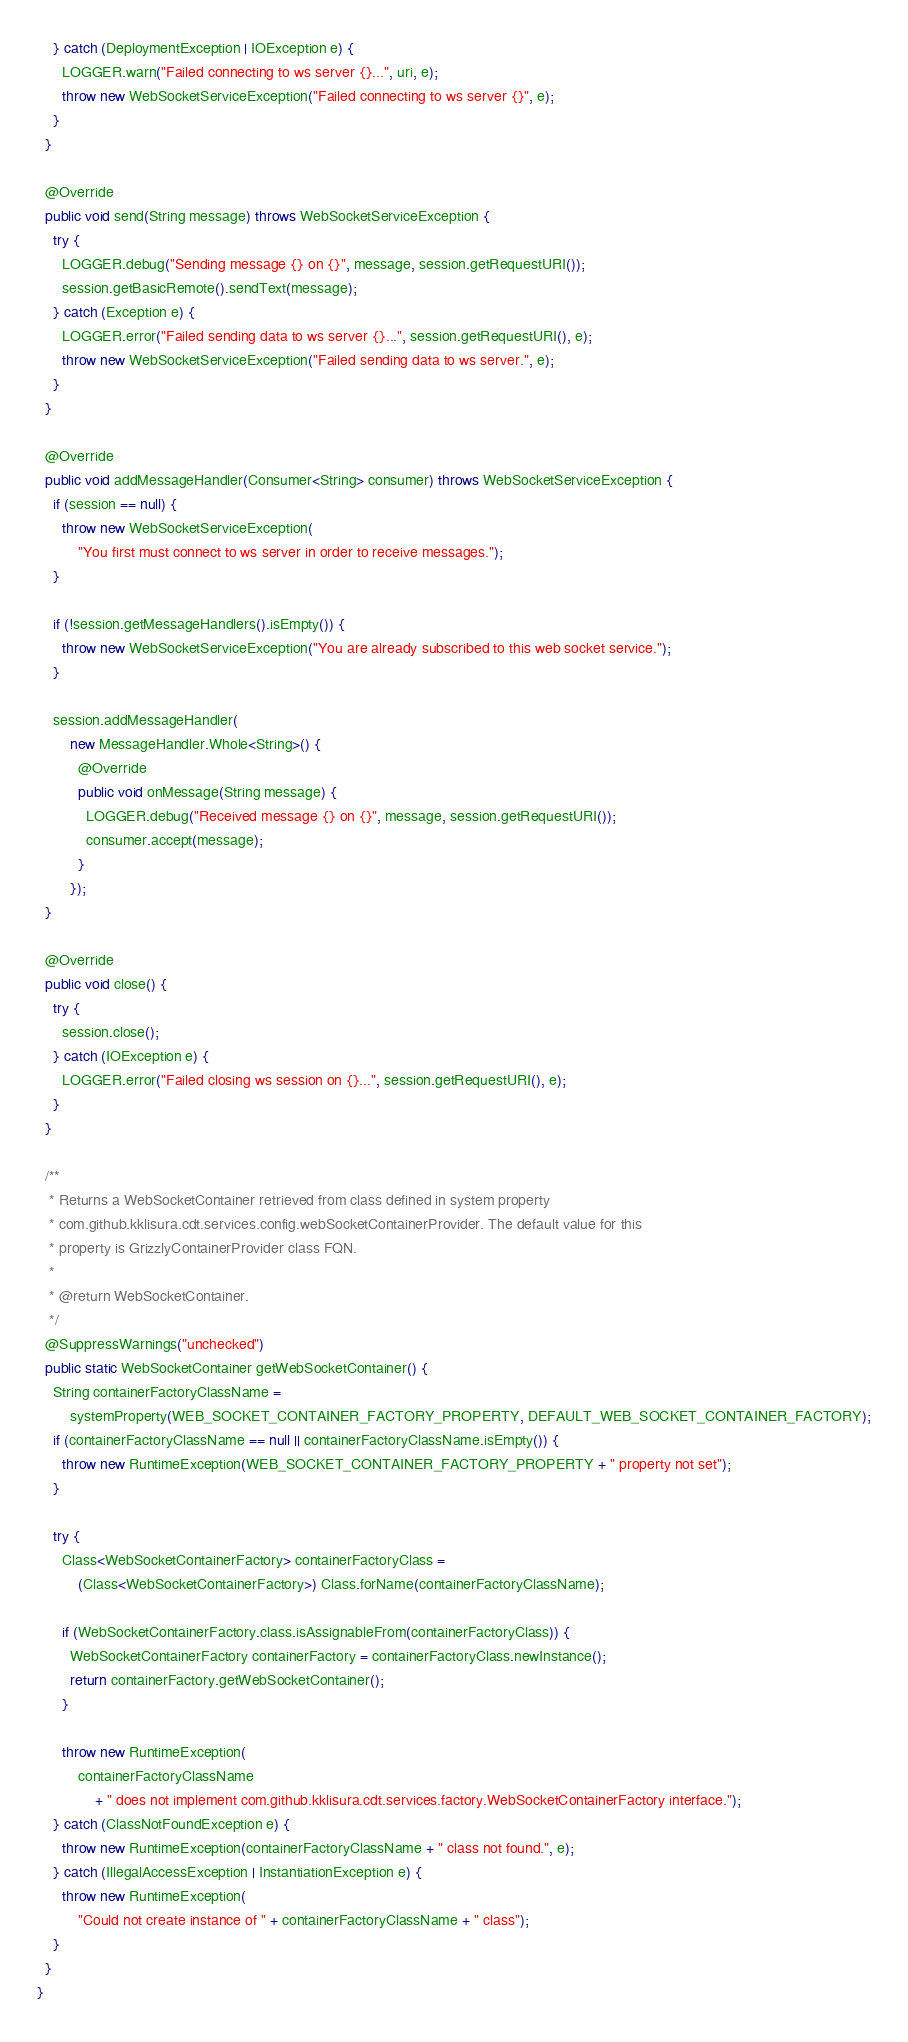Convert code to text. <code><loc_0><loc_0><loc_500><loc_500><_Java_>    } catch (DeploymentException | IOException e) {
      LOGGER.warn("Failed connecting to ws server {}...", uri, e);
      throw new WebSocketServiceException("Failed connecting to ws server {}", e);
    }
  }

  @Override
  public void send(String message) throws WebSocketServiceException {
    try {
      LOGGER.debug("Sending message {} on {}", message, session.getRequestURI());
      session.getBasicRemote().sendText(message);
    } catch (Exception e) {
      LOGGER.error("Failed sending data to ws server {}...", session.getRequestURI(), e);
      throw new WebSocketServiceException("Failed sending data to ws server.", e);
    }
  }

  @Override
  public void addMessageHandler(Consumer<String> consumer) throws WebSocketServiceException {
    if (session == null) {
      throw new WebSocketServiceException(
          "You first must connect to ws server in order to receive messages.");
    }

    if (!session.getMessageHandlers().isEmpty()) {
      throw new WebSocketServiceException("You are already subscribed to this web socket service.");
    }

    session.addMessageHandler(
        new MessageHandler.Whole<String>() {
          @Override
          public void onMessage(String message) {
            LOGGER.debug("Received message {} on {}", message, session.getRequestURI());
            consumer.accept(message);
          }
        });
  }

  @Override
  public void close() {
    try {
      session.close();
    } catch (IOException e) {
      LOGGER.error("Failed closing ws session on {}...", session.getRequestURI(), e);
    }
  }

  /**
   * Returns a WebSocketContainer retrieved from class defined in system property
   * com.github.kklisura.cdt.services.config.webSocketContainerProvider. The default value for this
   * property is GrizzlyContainerProvider class FQN.
   *
   * @return WebSocketContainer.
   */
  @SuppressWarnings("unchecked")
  public static WebSocketContainer getWebSocketContainer() {
    String containerFactoryClassName =
        systemProperty(WEB_SOCKET_CONTAINER_FACTORY_PROPERTY, DEFAULT_WEB_SOCKET_CONTAINER_FACTORY);
    if (containerFactoryClassName == null || containerFactoryClassName.isEmpty()) {
      throw new RuntimeException(WEB_SOCKET_CONTAINER_FACTORY_PROPERTY + " property not set");
    }

    try {
      Class<WebSocketContainerFactory> containerFactoryClass =
          (Class<WebSocketContainerFactory>) Class.forName(containerFactoryClassName);

      if (WebSocketContainerFactory.class.isAssignableFrom(containerFactoryClass)) {
        WebSocketContainerFactory containerFactory = containerFactoryClass.newInstance();
        return containerFactory.getWebSocketContainer();
      }

      throw new RuntimeException(
          containerFactoryClassName
              + " does not implement com.github.kklisura.cdt.services.factory.WebSocketContainerFactory interface.");
    } catch (ClassNotFoundException e) {
      throw new RuntimeException(containerFactoryClassName + " class not found.", e);
    } catch (IllegalAccessException | InstantiationException e) {
      throw new RuntimeException(
          "Could not create instance of " + containerFactoryClassName + " class");
    }
  }
}
</code> 